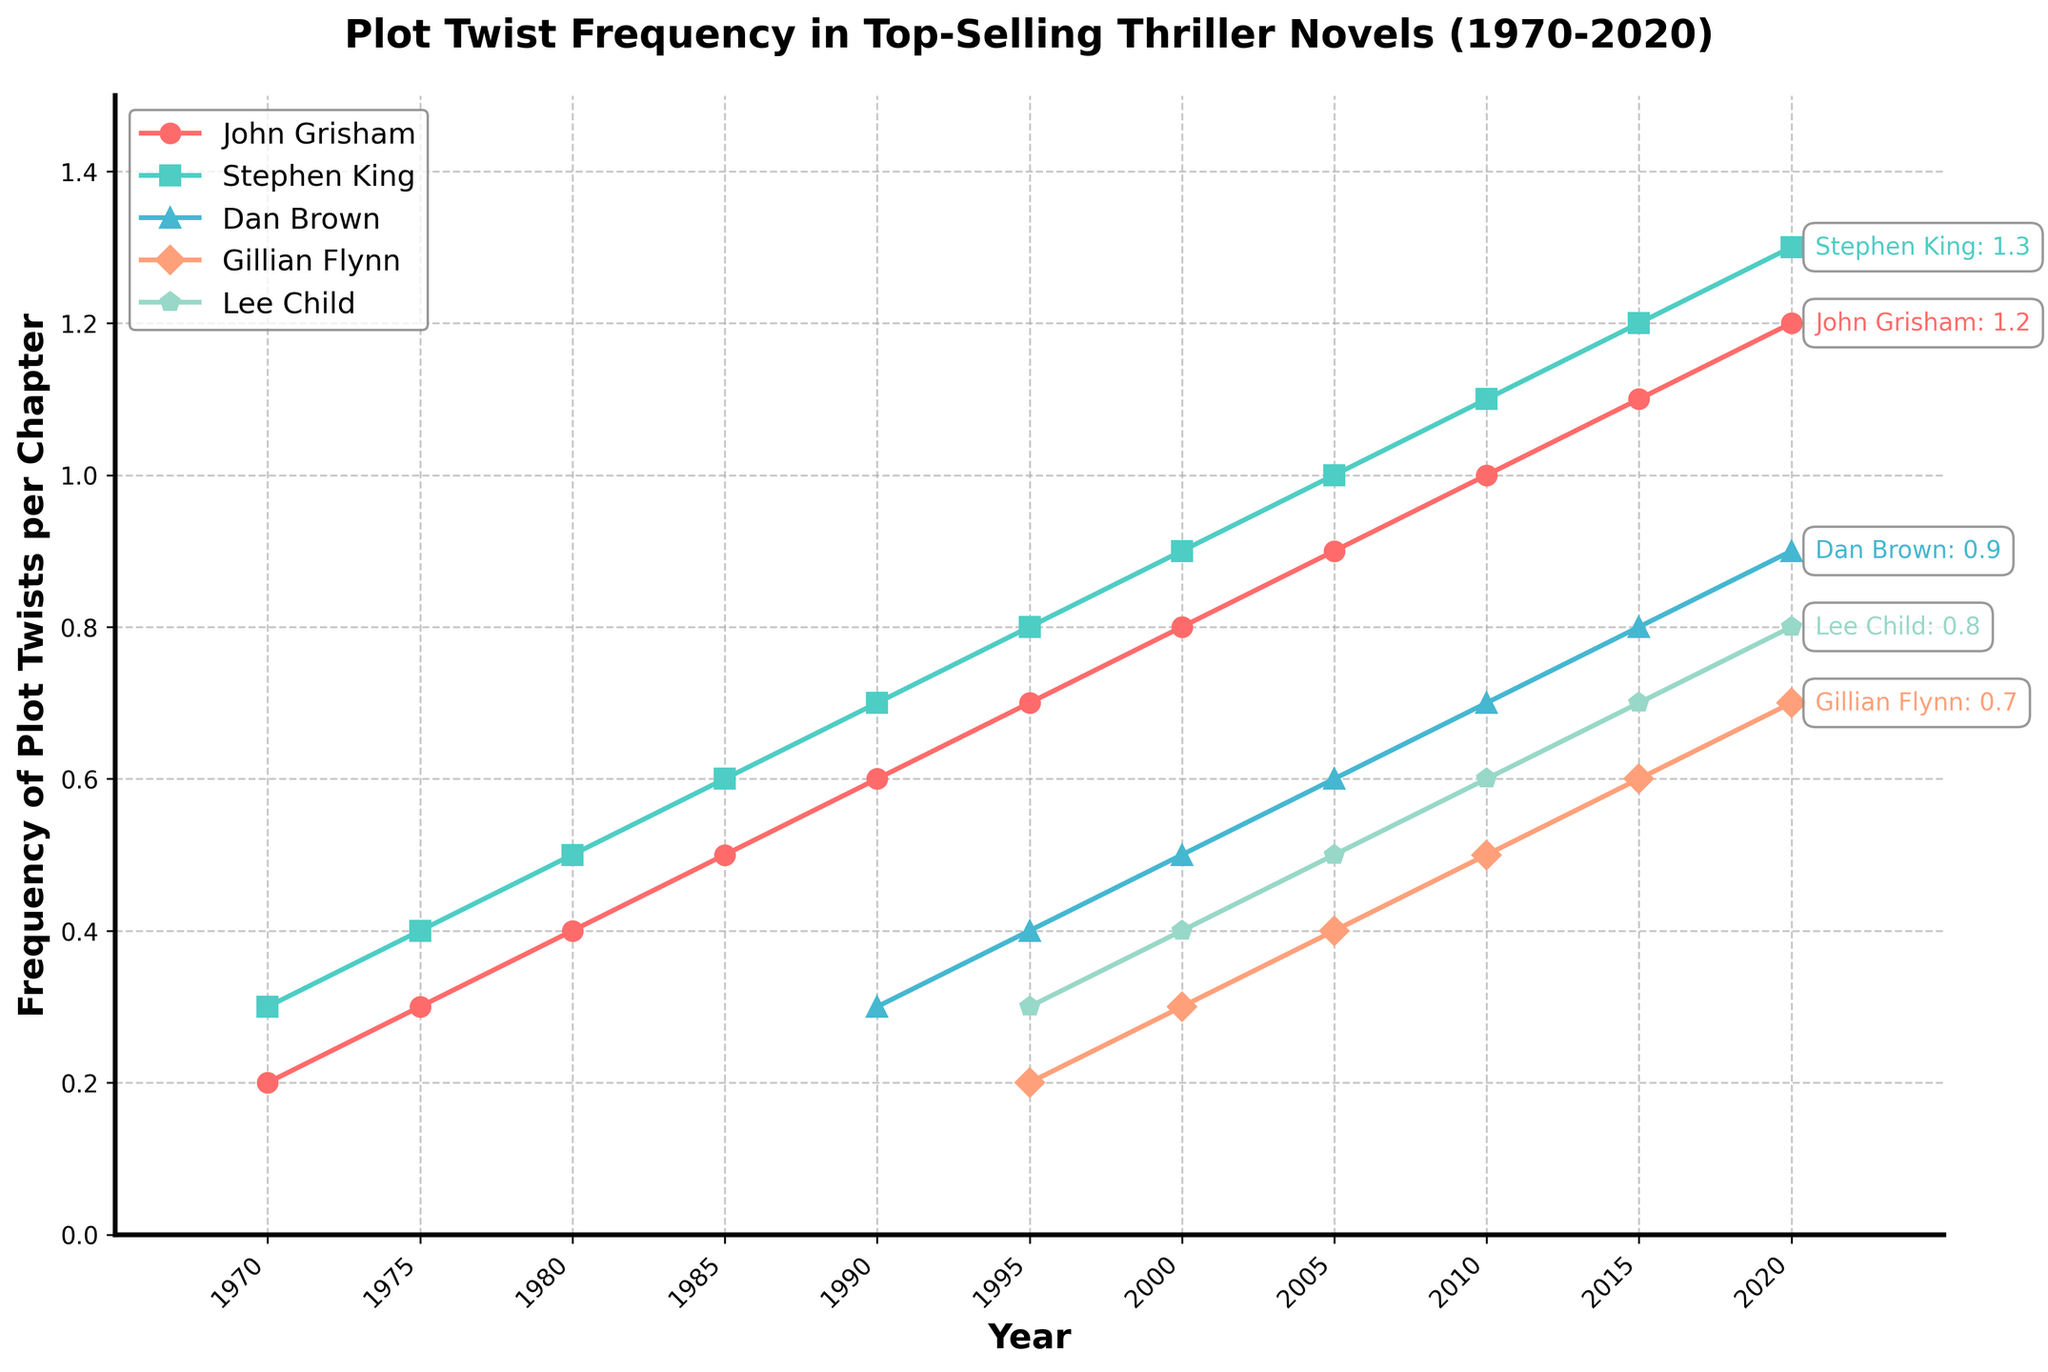What is the frequency of plot twists per chapter for John Grisham in 1990 compared to 2020? From the figure, locate the line corresponding to John Grisham. In 1990, the frequency is at 0.6, and in 2020, it rises to 1.2. By comparing these values, you'll see the frequency doubled over the 30-year period.
Answer: 0.6 in 1990 and 1.2 in 2020 How does the frequency of plot twists in Stephen King's novels change from 1970 to 2015? Referring to Stephen King's series (typically represented with a consistent color and/or marker), we see that in 1970, the frequency is 0.3. This increases steadily, reaching 1.2 by 2015.
Answer: Increases from 0.3 to 1.2 Which author had the highest frequency of plot twists per chapter in 2000? Inspect the data points for the year 2000 across the different lines representing the authors. Stephen King, with a frequency of 0.9, has the highest value that year.
Answer: Stephen King Compare the plot twist frequencies between Dan Brown and Gillian Flynn in 2005. Which author has a higher frequency? Observe the data points in 2005 for both Dan Brown and Gillian Flynn. Dan Brown has a frequency of 0.6, while Gillian Flynn is at 0.4. Hence, Dan Brown's plot twist frequency is higher.
Answer: Dan Brown What trend can you observe for Lee Child's plot twist frequency from 1995 to 2020? Look at the visual trend line for Lee Child. Starting at 0.3 in 1995, the line rises steadily, reaching 0.8 in 2020.
Answer: Increasing trend How do the changes in John Grisham's plot twist frequency compare from 1980 to 1990 and from 2010 to 2020? For John Grisham, the frequency changes from 0.4 in 1980 to 0.6 in 1990, an increase of 0.2. From 2010 to 2020, it changes from 1.0 to 1.2, also an increase of 0.2. The increases over both periods are identical.
Answer: Equal increases of 0.2 Which authors had equivalent plot twist frequencies in any year, according to the data? Look for any overlapping points across the lines representing different authors. In 2000, John Grisham and Gillian Flynn both had frequencies of 0.5.
Answer: John Grisham and Gillian Flynn in 2000 What is the total increase in plot twist frequency for Stephen King from 1970 to 2020? Identify Stephen King’s data points in 1970 and 2020, which are 0.3 and 1.3, respectively. The total increase is 1.3 - 0.3 = 1.0.
Answer: 1.0 What do you notice about the plot twist frequency trends for each author between 2000 and 2010? Analyze the slopes or changes in frequencies for each author between these years. All authors show an upward trend during this period.
Answer: All increasing In which year did John Grisham's plot twist frequency match Stephen King's frequency in 1985? Stephen King's frequency in 1985 is 0.6. Checking John Grisham’s frequency, it matches this value in 1990.
Answer: 1990 